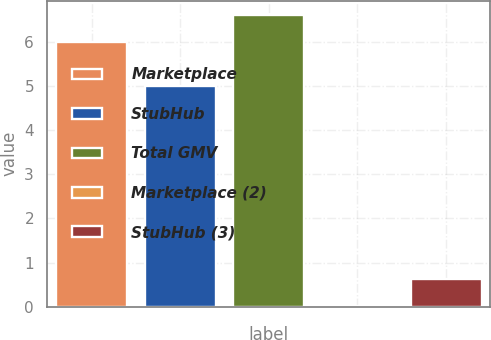<chart> <loc_0><loc_0><loc_500><loc_500><bar_chart><fcel>Marketplace<fcel>StubHub<fcel>Total GMV<fcel>Marketplace (2)<fcel>StubHub (3)<nl><fcel>6<fcel>5<fcel>6.6<fcel>0.02<fcel>0.62<nl></chart> 